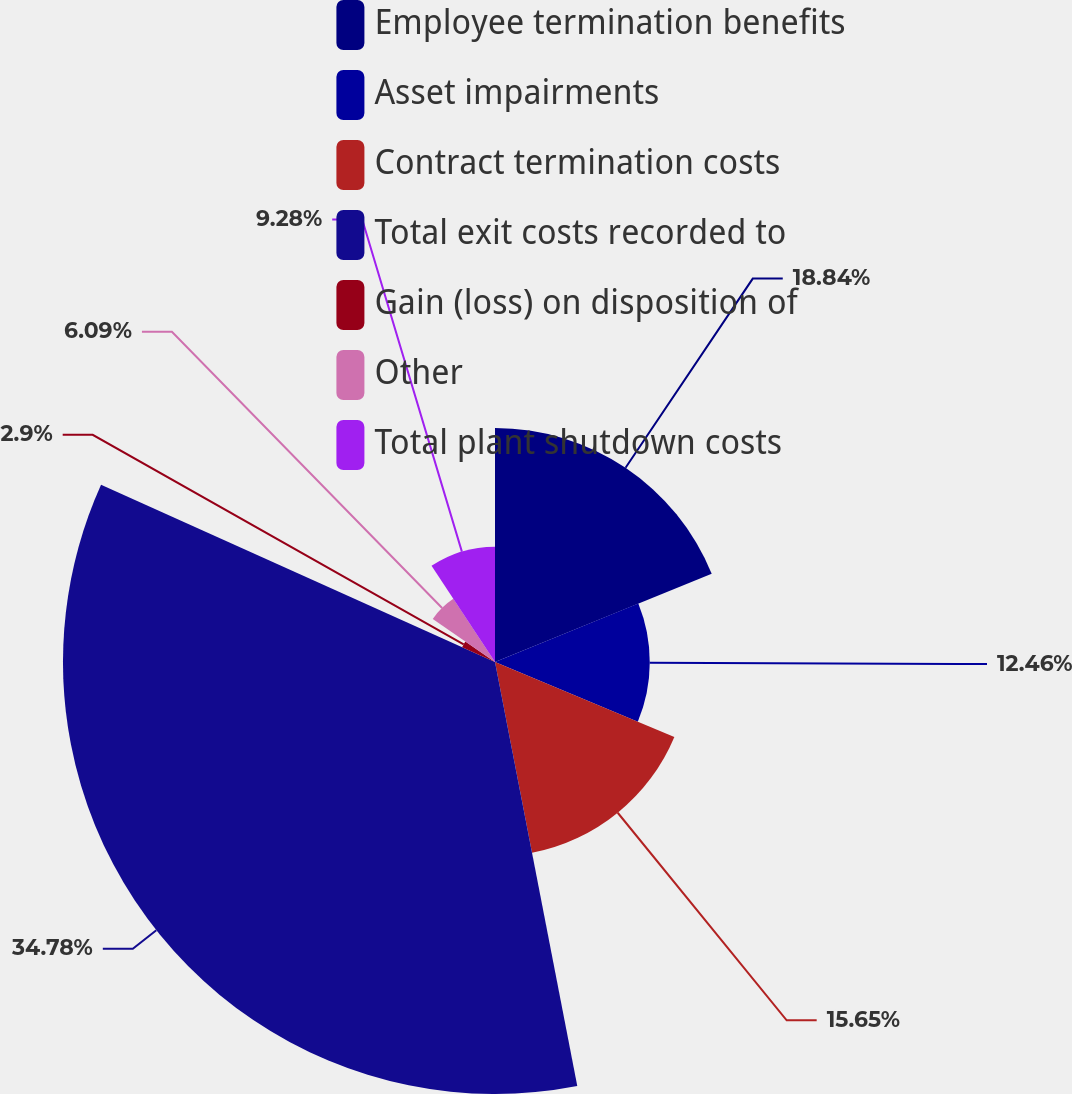Convert chart. <chart><loc_0><loc_0><loc_500><loc_500><pie_chart><fcel>Employee termination benefits<fcel>Asset impairments<fcel>Contract termination costs<fcel>Total exit costs recorded to<fcel>Gain (loss) on disposition of<fcel>Other<fcel>Total plant shutdown costs<nl><fcel>18.84%<fcel>12.46%<fcel>15.65%<fcel>34.78%<fcel>2.9%<fcel>6.09%<fcel>9.28%<nl></chart> 